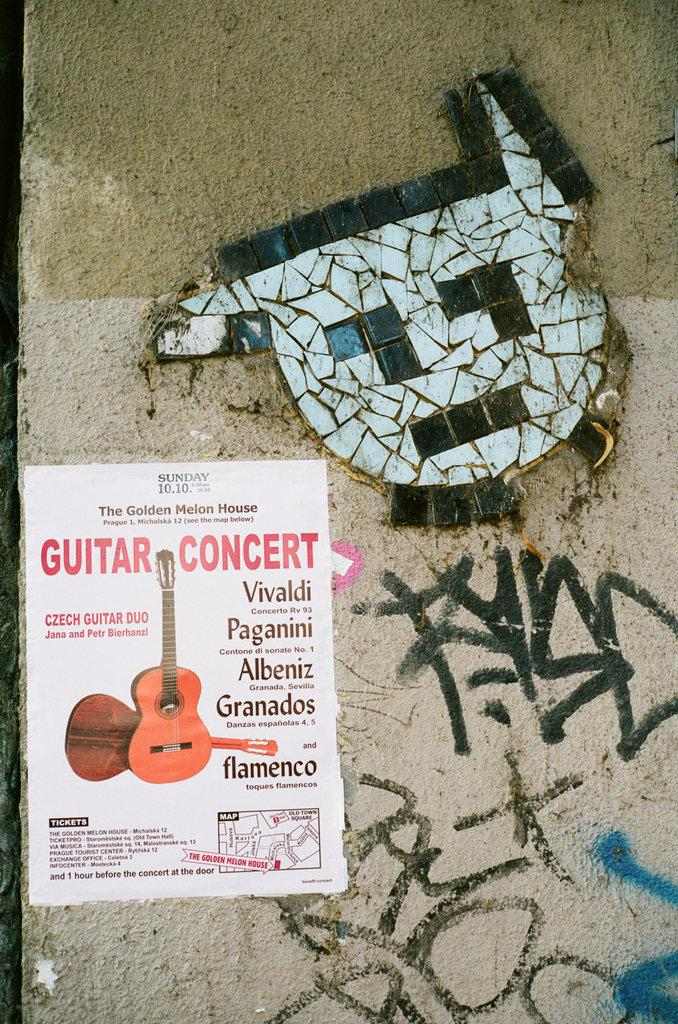Provide a one-sentence caption for the provided image. A poster on a wall promoting a guitar concert. 